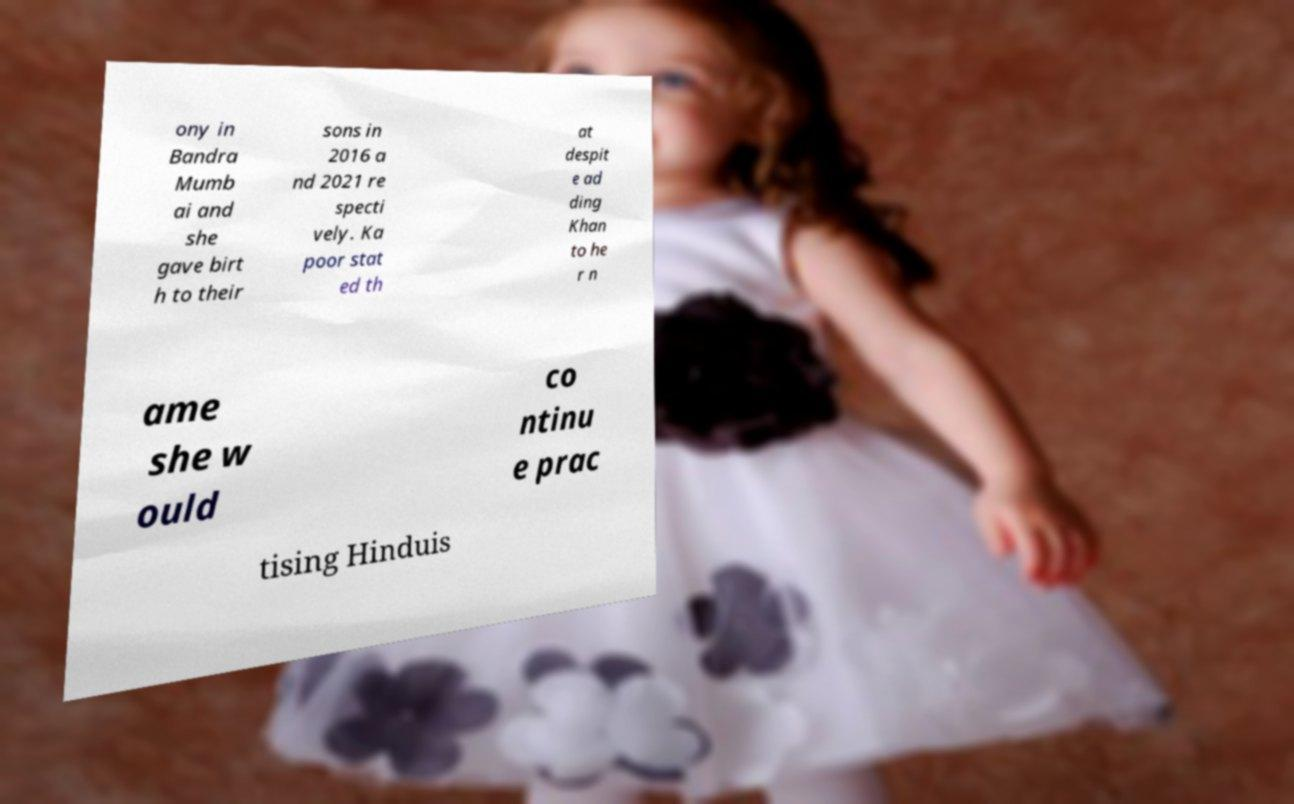Please read and relay the text visible in this image. What does it say? ony in Bandra Mumb ai and she gave birt h to their sons in 2016 a nd 2021 re specti vely. Ka poor stat ed th at despit e ad ding Khan to he r n ame she w ould co ntinu e prac tising Hinduis 